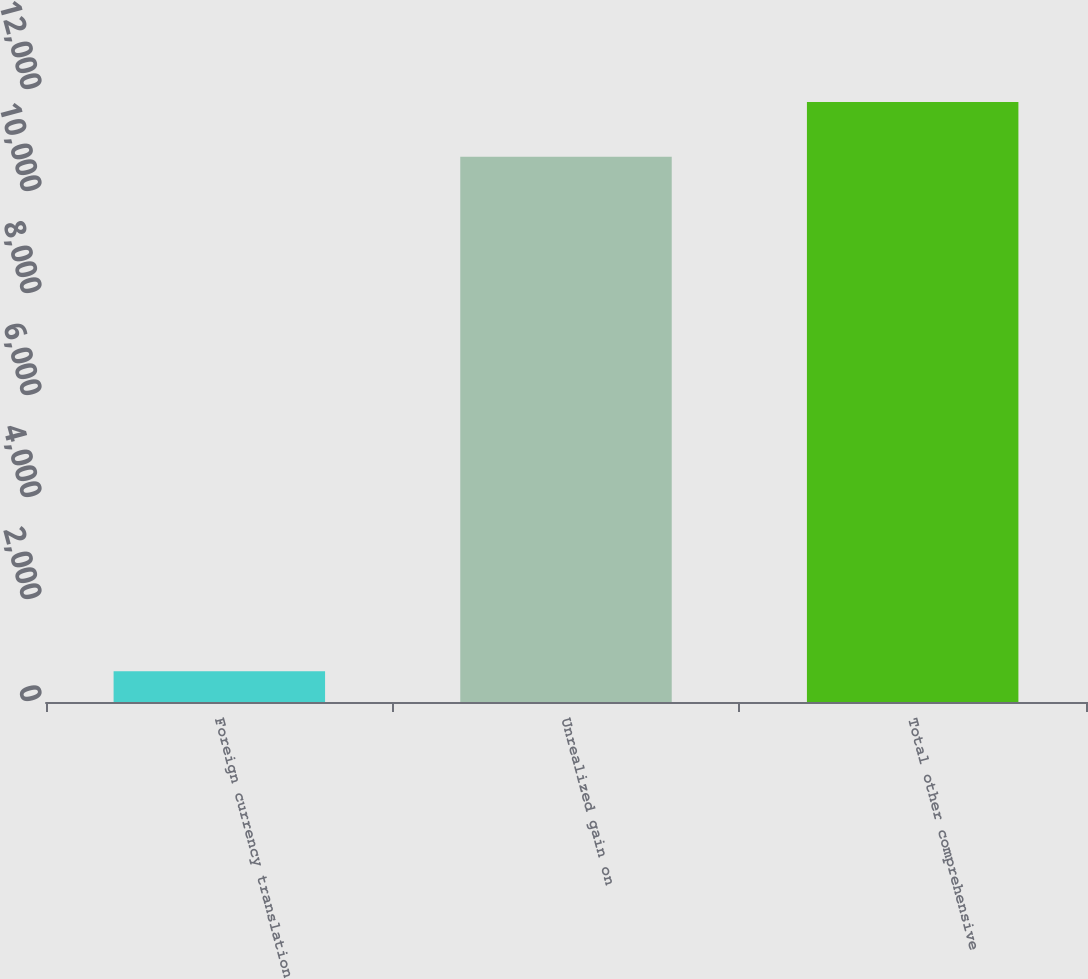Convert chart to OTSL. <chart><loc_0><loc_0><loc_500><loc_500><bar_chart><fcel>Foreign currency translation<fcel>Unrealized gain on<fcel>Total other comprehensive<nl><fcel>601<fcel>10693<fcel>11762.3<nl></chart> 